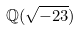Convert formula to latex. <formula><loc_0><loc_0><loc_500><loc_500>\mathbb { Q } ( \sqrt { - 2 3 } )</formula> 